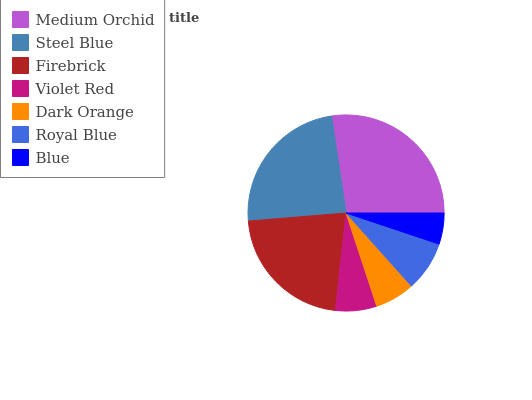Is Blue the minimum?
Answer yes or no. Yes. Is Medium Orchid the maximum?
Answer yes or no. Yes. Is Steel Blue the minimum?
Answer yes or no. No. Is Steel Blue the maximum?
Answer yes or no. No. Is Medium Orchid greater than Steel Blue?
Answer yes or no. Yes. Is Steel Blue less than Medium Orchid?
Answer yes or no. Yes. Is Steel Blue greater than Medium Orchid?
Answer yes or no. No. Is Medium Orchid less than Steel Blue?
Answer yes or no. No. Is Royal Blue the high median?
Answer yes or no. Yes. Is Royal Blue the low median?
Answer yes or no. Yes. Is Blue the high median?
Answer yes or no. No. Is Violet Red the low median?
Answer yes or no. No. 